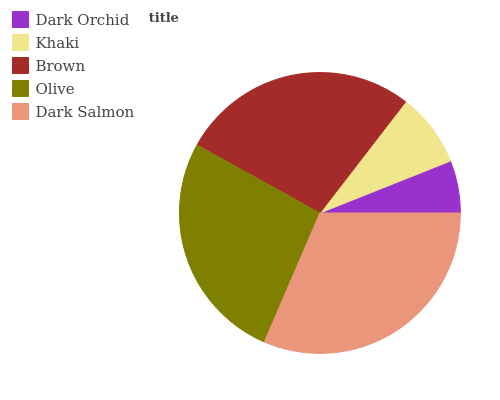Is Dark Orchid the minimum?
Answer yes or no. Yes. Is Dark Salmon the maximum?
Answer yes or no. Yes. Is Khaki the minimum?
Answer yes or no. No. Is Khaki the maximum?
Answer yes or no. No. Is Khaki greater than Dark Orchid?
Answer yes or no. Yes. Is Dark Orchid less than Khaki?
Answer yes or no. Yes. Is Dark Orchid greater than Khaki?
Answer yes or no. No. Is Khaki less than Dark Orchid?
Answer yes or no. No. Is Olive the high median?
Answer yes or no. Yes. Is Olive the low median?
Answer yes or no. Yes. Is Khaki the high median?
Answer yes or no. No. Is Khaki the low median?
Answer yes or no. No. 